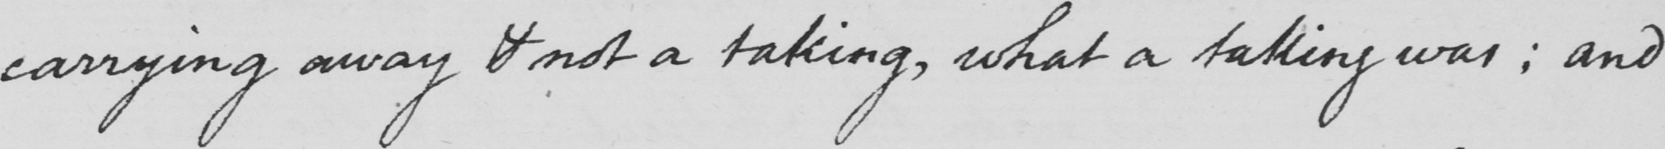What does this handwritten line say? carrying away & not a taking , what a taking was ; and 